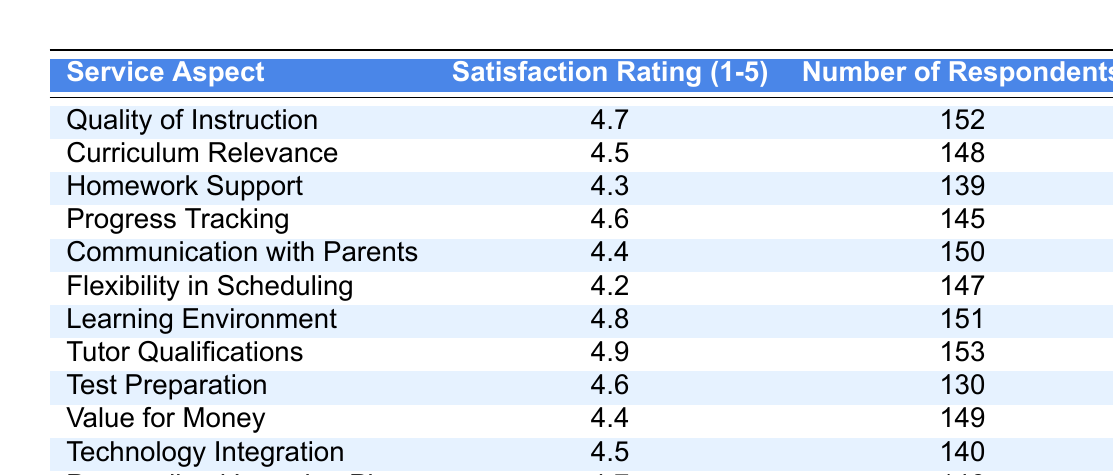What is the satisfaction rating for Tutor Qualifications? The satisfaction rating for Tutor Qualifications is listed in the table under the column "Satisfaction Rating (1-5)" next to that service aspect. It shows a rating of 4.9.
Answer: 4.9 How many respondents rated the Quality of Instruction? The number of respondents for Quality of Instruction is provided in the table under the column "Number of Respondents." It shows that 152 respondents rated this aspect.
Answer: 152 What is the average satisfaction rating for all the service aspects combined? To find the average, first sum the satisfaction ratings: 4.7 + 4.5 + 4.3 + 4.6 + 4.4 + 4.2 + 4.8 + 4.9 + 4.6 + 4.4 + 4.5 + 4.7 = 54.6. Then, divide by the number of service aspects, which is 12: 54.6 / 12 = 4.55.
Answer: 4.55 Is the satisfaction rating for Flexibility in Scheduling higher than the rating for Homework Support? By referring to the table, the satisfaction rating for Flexibility in Scheduling is 4.2 and for Homework Support is 4.3. Since 4.2 is less than 4.3, the statement is false.
Answer: No Which service aspect received the highest satisfaction rating? By reviewing the satisfaction ratings in the table, Tutor Qualifications has the highest rating at 4.9.
Answer: Tutor Qualifications How many more respondents rated Learning Environment compared to Test Preparation? The number of respondents for Learning Environment is 151, and for Test Preparation, it is 130. To find the difference, subtract 130 from 151, resulting in 21 more respondents.
Answer: 21 Is the overall satisfaction rating for all aspects above 4.5? The average satisfaction rating calculated previously is 4.55, which is indeed above 4.5. Thus, the overall satisfaction rating for all aspects is above this threshold.
Answer: Yes What percentage of respondents rated Communication with Parents? The number of respondents who rated Communication with Parents is 150. To find the percentage of total respondents (152 + 148 + 139 + ... + 146 = 1762), divide 150 by 1762 and multiply by 100 to get approximately 8.5%.
Answer: 8.5% Which two aspects have the closest satisfaction ratings? Comparing the satisfaction ratings, Communication with Parents (4.4) and Value for Money (4.4) have the same rating, thus are the closest.
Answer: Communication with Parents and Value for Money What is the satisfaction rating range among the service aspects? The highest rating is 4.9 (Tutor Qualifications) and the lowest is 4.2 (Flexibility in Scheduling). To find the range, subtract the lowest from the highest: 4.9 - 4.2 = 0.7.
Answer: 0.7 